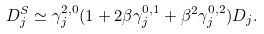<formula> <loc_0><loc_0><loc_500><loc_500>D _ { j } ^ { S } \simeq \gamma ^ { 2 , 0 } _ { j } ( 1 + 2 \beta \gamma ^ { 0 , 1 } _ { j } + \beta ^ { 2 } \gamma ^ { 0 , 2 } _ { j } ) D _ { j } .</formula> 